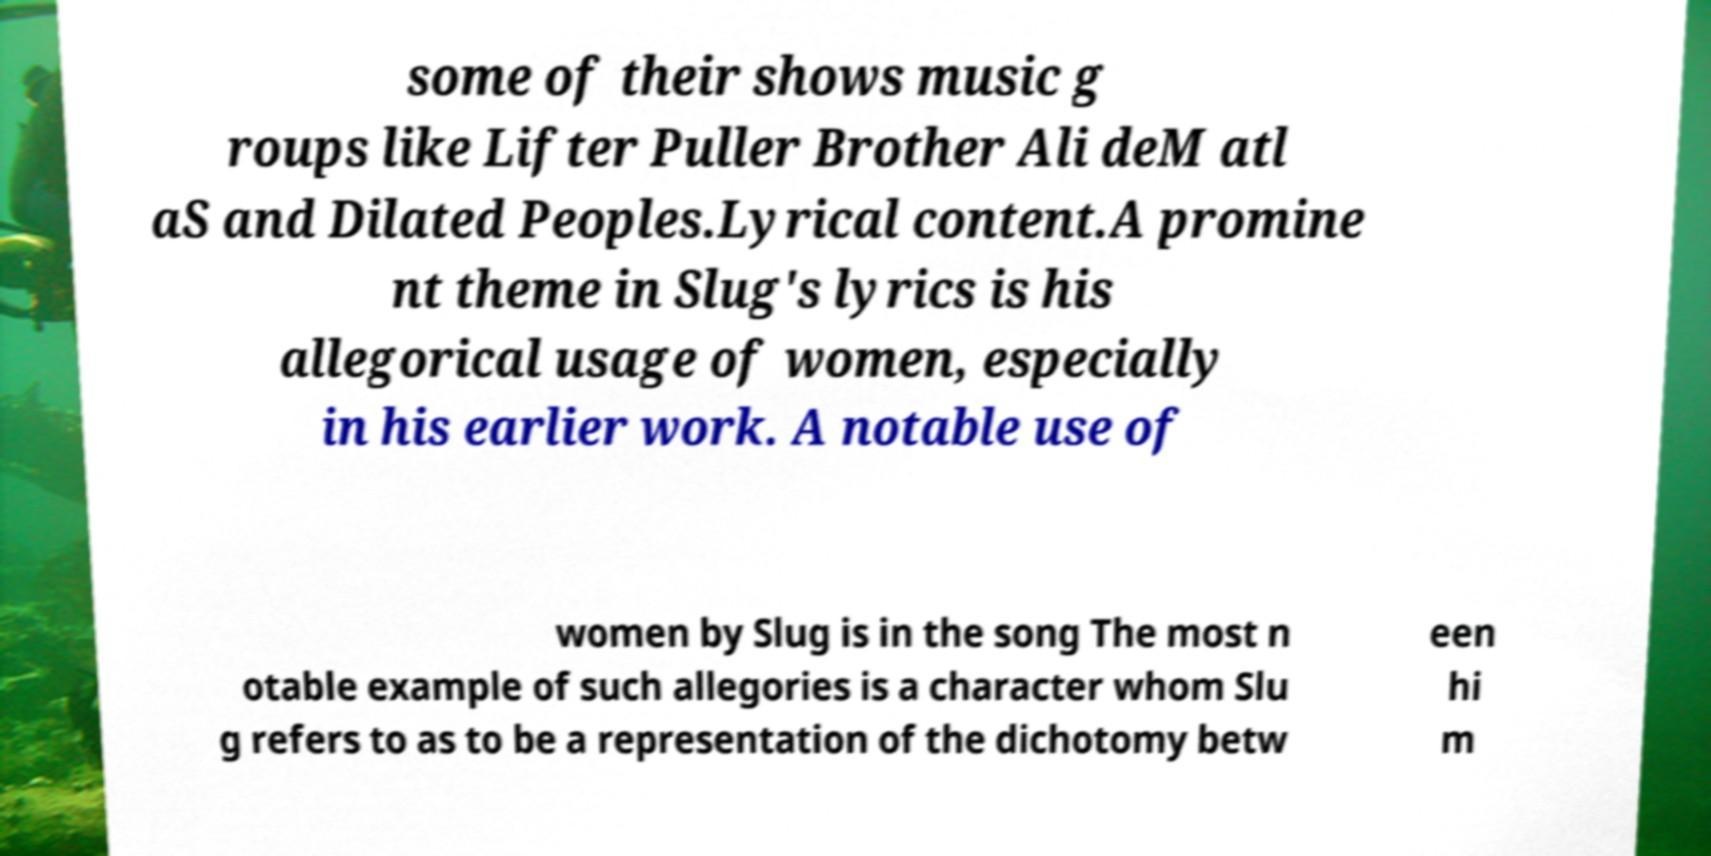Please read and relay the text visible in this image. What does it say? some of their shows music g roups like Lifter Puller Brother Ali deM atl aS and Dilated Peoples.Lyrical content.A promine nt theme in Slug's lyrics is his allegorical usage of women, especially in his earlier work. A notable use of women by Slug is in the song The most n otable example of such allegories is a character whom Slu g refers to as to be a representation of the dichotomy betw een hi m 